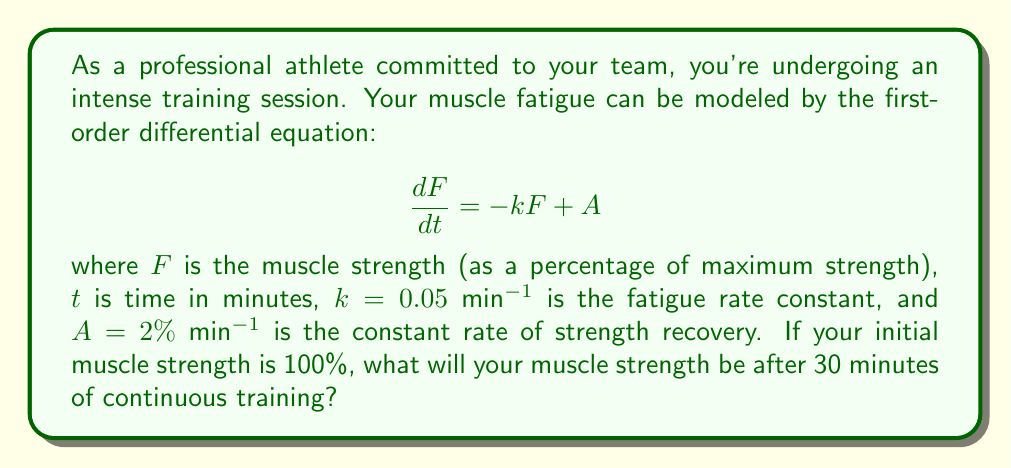Can you solve this math problem? To solve this problem, we need to follow these steps:

1) The given differential equation is:

   $$\frac{dF}{dt} = -kF + A$$

2) This is a first-order linear differential equation. The general solution is:

   $$F(t) = Ce^{-kt} + \frac{A}{k}$$

   where $C$ is a constant to be determined from the initial condition.

3) We're given that $k = 0.05$ min$^{-1}$ and $A = 2\%$ min$^{-1}$. Let's substitute these:

   $$F(t) = Ce^{-0.05t} + \frac{2}{0.05} = Ce^{-0.05t} + 40$$

4) Now, we use the initial condition. At $t = 0$, $F = 100\%$:

   $$100 = C + 40$$
   $$C = 60$$

5) So our specific solution is:

   $$F(t) = 60e^{-0.05t} + 40$$

6) To find the muscle strength after 30 minutes, we substitute $t = 30$:

   $$F(30) = 60e^{-0.05(30)} + 40$$
   $$= 60e^{-1.5} + 40$$
   $$\approx 60(0.2231) + 40$$
   $$\approx 13.39 + 40$$
   $$\approx 53.39\%$$

Therefore, after 30 minutes of continuous training, your muscle strength will be approximately 53.39% of your maximum strength.
Answer: 53.39% 